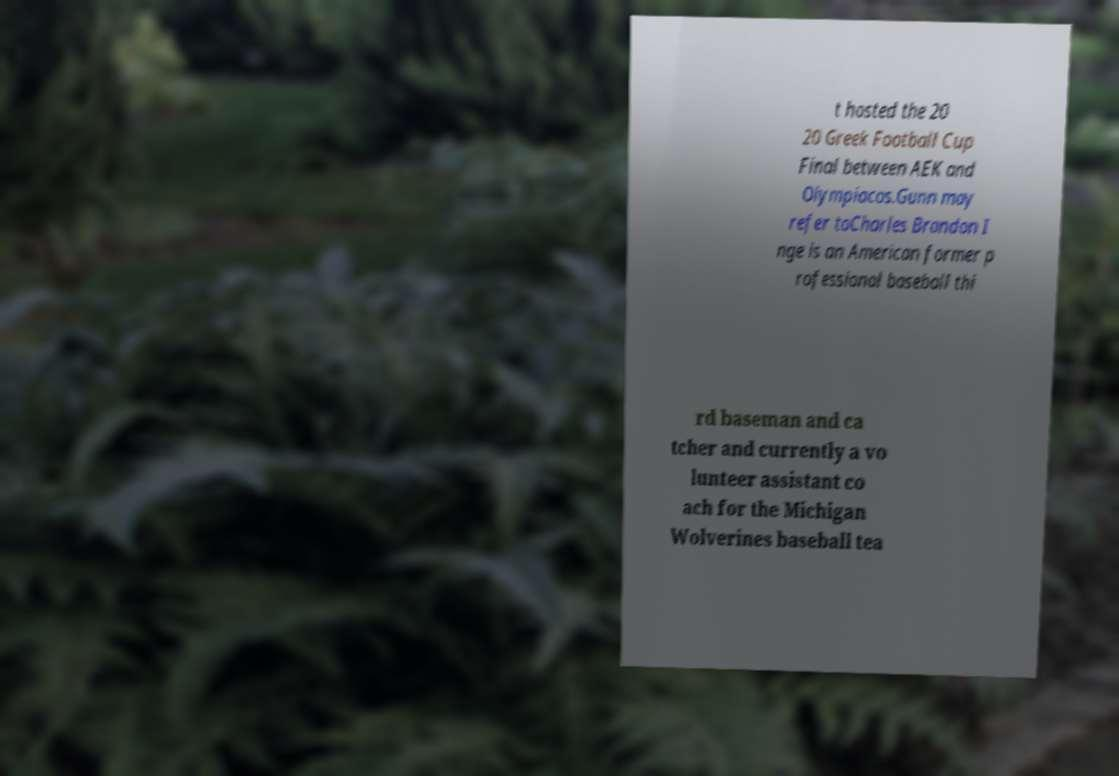For documentation purposes, I need the text within this image transcribed. Could you provide that? t hosted the 20 20 Greek Football Cup Final between AEK and Olympiacos.Gunn may refer toCharles Brandon I nge is an American former p rofessional baseball thi rd baseman and ca tcher and currently a vo lunteer assistant co ach for the Michigan Wolverines baseball tea 